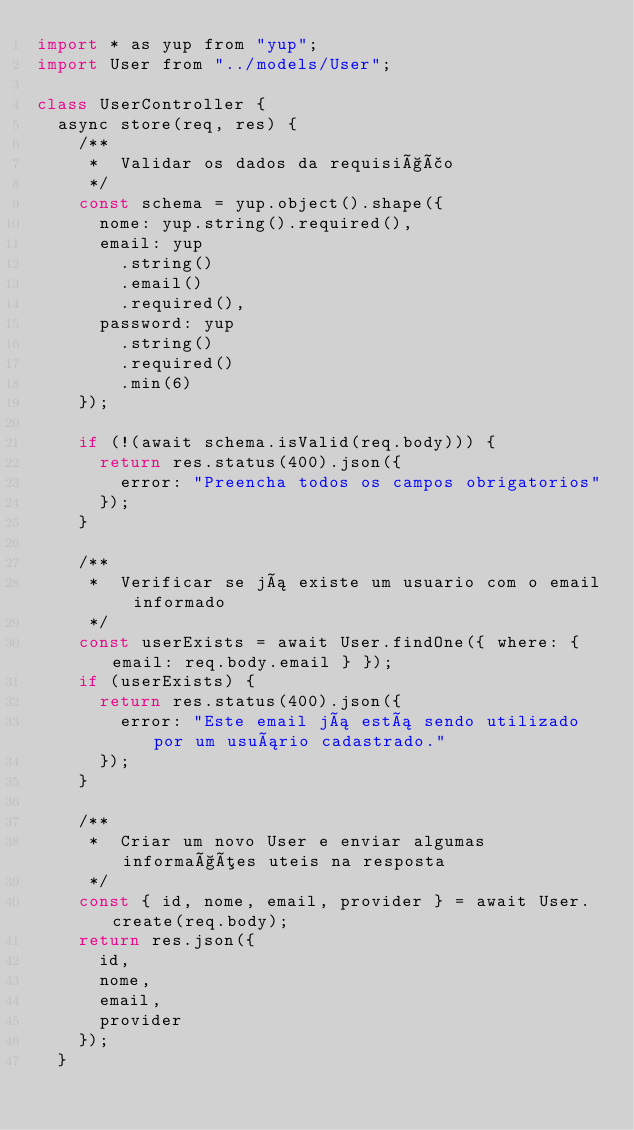Convert code to text. <code><loc_0><loc_0><loc_500><loc_500><_JavaScript_>import * as yup from "yup";
import User from "../models/User";

class UserController {
  async store(req, res) {
    /**
     *  Validar os dados da requisição
     */
    const schema = yup.object().shape({
      nome: yup.string().required(),
      email: yup
        .string()
        .email()
        .required(),
      password: yup
        .string()
        .required()
        .min(6)
    });

    if (!(await schema.isValid(req.body))) {
      return res.status(400).json({
        error: "Preencha todos os campos obrigatorios"
      });
    }

    /**
     *  Verificar se já existe um usuario com o email informado
     */
    const userExists = await User.findOne({ where: { email: req.body.email } });
    if (userExists) {
      return res.status(400).json({
        error: "Este email já está sendo utilizado por um usuário cadastrado."
      });
    }

    /**
     *  Criar um novo User e enviar algumas informações uteis na resposta
     */
    const { id, nome, email, provider } = await User.create(req.body);
    return res.json({
      id,
      nome,
      email,
      provider
    });
  }
</code> 